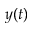<formula> <loc_0><loc_0><loc_500><loc_500>y ( t )</formula> 